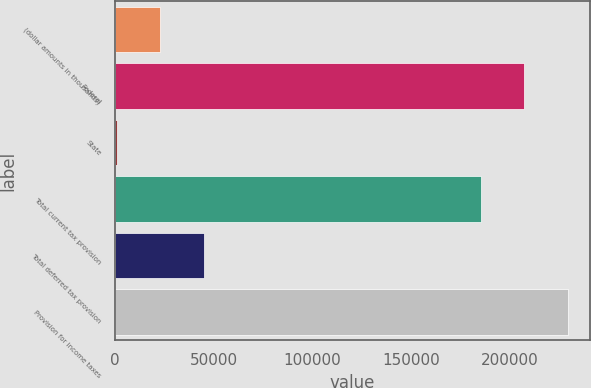Convert chart to OTSL. <chart><loc_0><loc_0><loc_500><loc_500><bar_chart><fcel>(dollar amounts in thousands)<fcel>Federal<fcel>State<fcel>Total current tax provision<fcel>Total deferred tax provision<fcel>Provision for income taxes<nl><fcel>22974.6<fcel>207377<fcel>1017<fcel>185419<fcel>44932.2<fcel>229334<nl></chart> 